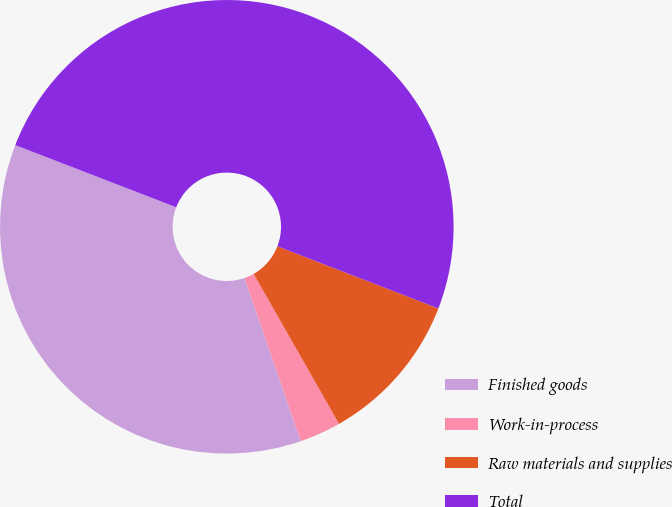<chart> <loc_0><loc_0><loc_500><loc_500><pie_chart><fcel>Finished goods<fcel>Work-in-process<fcel>Raw materials and supplies<fcel>Total<nl><fcel>36.15%<fcel>2.95%<fcel>10.9%<fcel>50.0%<nl></chart> 